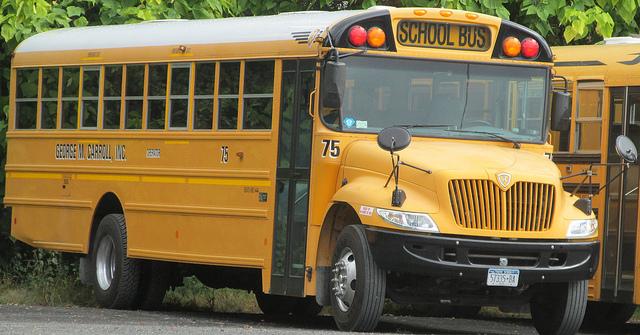Is this a school bus?
Write a very short answer. Yes. What is the bus number?
Short answer required. 75. How many windows are on the right side of the bus?
Quick response, please. 11. 